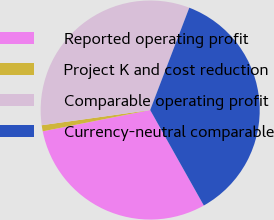Convert chart to OTSL. <chart><loc_0><loc_0><loc_500><loc_500><pie_chart><fcel>Reported operating profit<fcel>Project K and cost reduction<fcel>Comparable operating profit<fcel>Currency-neutral comparable<nl><fcel>30.03%<fcel>0.9%<fcel>33.03%<fcel>36.04%<nl></chart> 